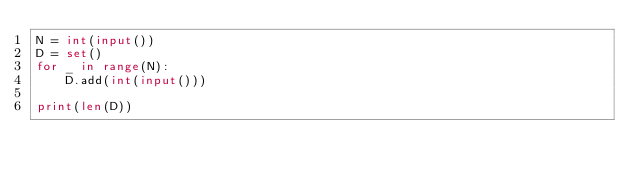Convert code to text. <code><loc_0><loc_0><loc_500><loc_500><_Python_>N = int(input())
D = set()
for _ in range(N):
    D.add(int(input()))

print(len(D))</code> 